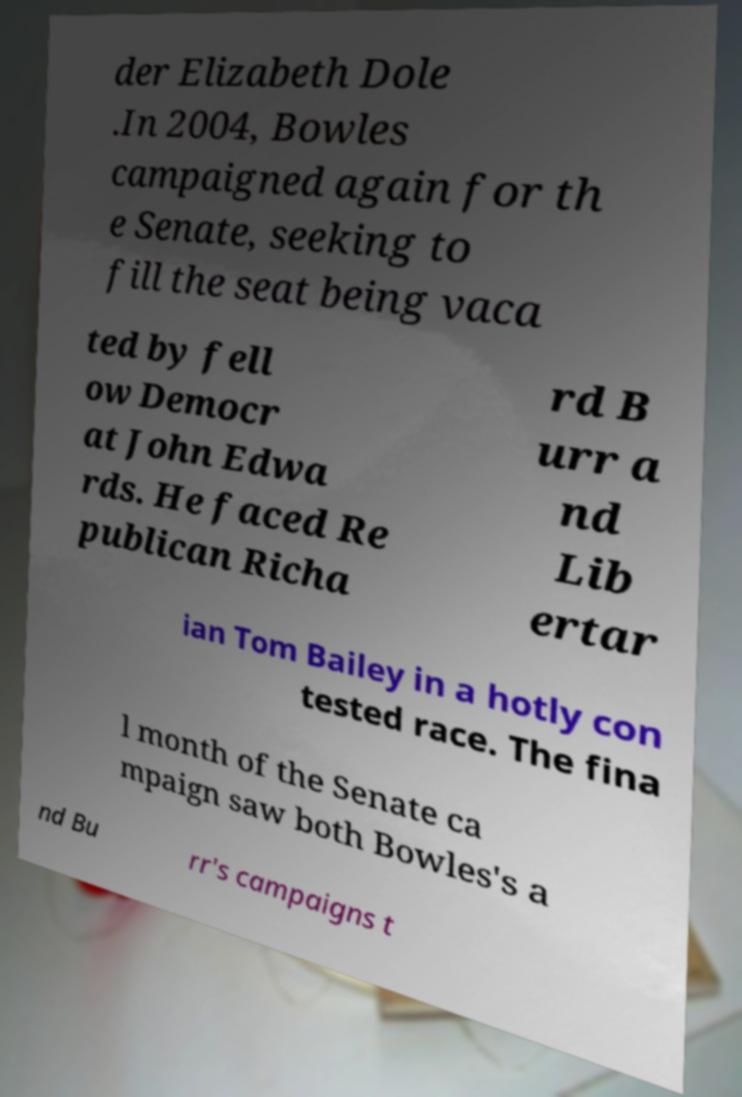Can you accurately transcribe the text from the provided image for me? der Elizabeth Dole .In 2004, Bowles campaigned again for th e Senate, seeking to fill the seat being vaca ted by fell ow Democr at John Edwa rds. He faced Re publican Richa rd B urr a nd Lib ertar ian Tom Bailey in a hotly con tested race. The fina l month of the Senate ca mpaign saw both Bowles's a nd Bu rr's campaigns t 